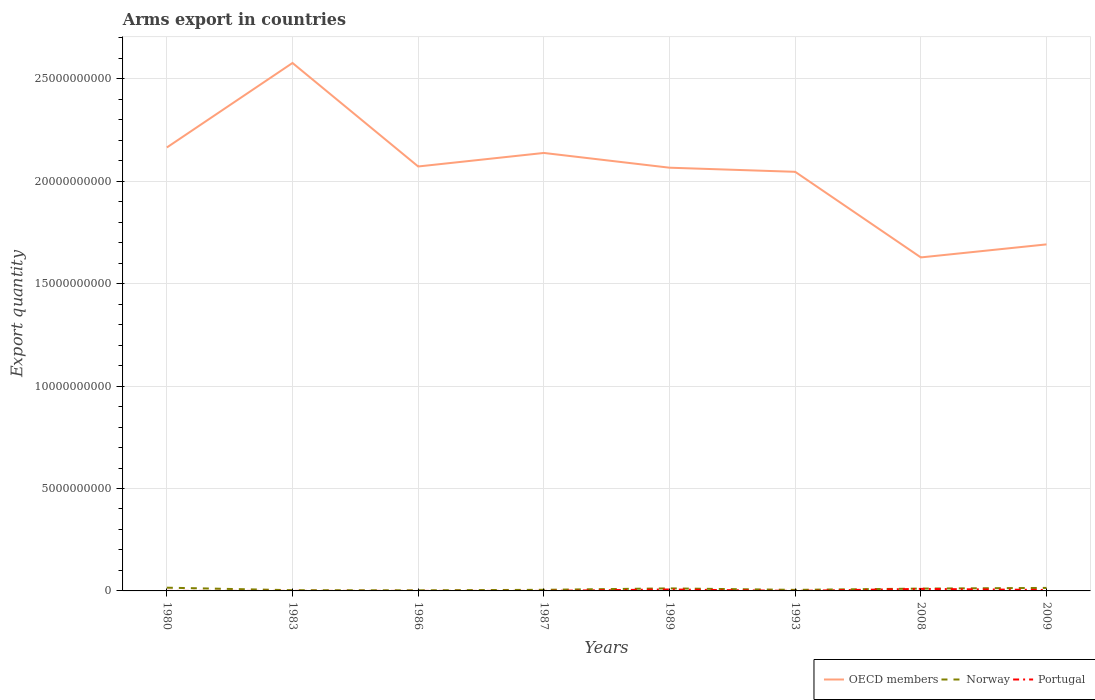Does the line corresponding to Portugal intersect with the line corresponding to Norway?
Your response must be concise. No. Across all years, what is the maximum total arms export in Norway?
Ensure brevity in your answer.  2.90e+07. What is the difference between the highest and the second highest total arms export in Norway?
Your response must be concise. 1.29e+08. What is the difference between the highest and the lowest total arms export in OECD members?
Provide a succinct answer. 5. Is the total arms export in Norway strictly greater than the total arms export in OECD members over the years?
Provide a short and direct response. Yes. Are the values on the major ticks of Y-axis written in scientific E-notation?
Offer a terse response. No. What is the title of the graph?
Offer a very short reply. Arms export in countries. Does "Northern Mariana Islands" appear as one of the legend labels in the graph?
Offer a terse response. No. What is the label or title of the Y-axis?
Your response must be concise. Export quantity. What is the Export quantity of OECD members in 1980?
Ensure brevity in your answer.  2.16e+1. What is the Export quantity in Norway in 1980?
Give a very brief answer. 1.58e+08. What is the Export quantity in OECD members in 1983?
Ensure brevity in your answer.  2.58e+1. What is the Export quantity of Norway in 1983?
Offer a very short reply. 3.50e+07. What is the Export quantity of Portugal in 1983?
Ensure brevity in your answer.  1.00e+06. What is the Export quantity in OECD members in 1986?
Give a very brief answer. 2.07e+1. What is the Export quantity of Norway in 1986?
Your answer should be compact. 2.90e+07. What is the Export quantity of OECD members in 1987?
Offer a terse response. 2.14e+1. What is the Export quantity in Norway in 1987?
Your answer should be compact. 5.40e+07. What is the Export quantity of OECD members in 1989?
Offer a terse response. 2.07e+1. What is the Export quantity of Norway in 1989?
Your answer should be compact. 1.24e+08. What is the Export quantity of Portugal in 1989?
Provide a short and direct response. 7.10e+07. What is the Export quantity of OECD members in 1993?
Provide a succinct answer. 2.05e+1. What is the Export quantity in Norway in 1993?
Your answer should be compact. 5.10e+07. What is the Export quantity of Portugal in 1993?
Your answer should be very brief. 1.00e+06. What is the Export quantity in OECD members in 2008?
Provide a short and direct response. 1.63e+1. What is the Export quantity in Norway in 2008?
Ensure brevity in your answer.  1.14e+08. What is the Export quantity in Portugal in 2008?
Your answer should be very brief. 9.90e+07. What is the Export quantity in OECD members in 2009?
Offer a terse response. 1.69e+1. What is the Export quantity of Norway in 2009?
Give a very brief answer. 1.47e+08. What is the Export quantity in Portugal in 2009?
Provide a succinct answer. 4.60e+07. Across all years, what is the maximum Export quantity of OECD members?
Provide a short and direct response. 2.58e+1. Across all years, what is the maximum Export quantity of Norway?
Offer a terse response. 1.58e+08. Across all years, what is the maximum Export quantity of Portugal?
Provide a succinct answer. 9.90e+07. Across all years, what is the minimum Export quantity of OECD members?
Your response must be concise. 1.63e+1. Across all years, what is the minimum Export quantity of Norway?
Keep it short and to the point. 2.90e+07. What is the total Export quantity in OECD members in the graph?
Your answer should be compact. 1.64e+11. What is the total Export quantity of Norway in the graph?
Make the answer very short. 7.12e+08. What is the total Export quantity of Portugal in the graph?
Make the answer very short. 2.21e+08. What is the difference between the Export quantity in OECD members in 1980 and that in 1983?
Your response must be concise. -4.13e+09. What is the difference between the Export quantity in Norway in 1980 and that in 1983?
Your response must be concise. 1.23e+08. What is the difference between the Export quantity in Portugal in 1980 and that in 1983?
Give a very brief answer. 0. What is the difference between the Export quantity in OECD members in 1980 and that in 1986?
Provide a short and direct response. 9.27e+08. What is the difference between the Export quantity in Norway in 1980 and that in 1986?
Provide a succinct answer. 1.29e+08. What is the difference between the Export quantity in Portugal in 1980 and that in 1986?
Your response must be concise. 0. What is the difference between the Export quantity of OECD members in 1980 and that in 1987?
Your answer should be very brief. 2.67e+08. What is the difference between the Export quantity of Norway in 1980 and that in 1987?
Make the answer very short. 1.04e+08. What is the difference between the Export quantity in Portugal in 1980 and that in 1987?
Provide a succinct answer. 0. What is the difference between the Export quantity of OECD members in 1980 and that in 1989?
Keep it short and to the point. 9.87e+08. What is the difference between the Export quantity in Norway in 1980 and that in 1989?
Give a very brief answer. 3.40e+07. What is the difference between the Export quantity of Portugal in 1980 and that in 1989?
Your response must be concise. -7.00e+07. What is the difference between the Export quantity in OECD members in 1980 and that in 1993?
Your answer should be very brief. 1.19e+09. What is the difference between the Export quantity in Norway in 1980 and that in 1993?
Your answer should be very brief. 1.07e+08. What is the difference between the Export quantity of Portugal in 1980 and that in 1993?
Your answer should be compact. 0. What is the difference between the Export quantity of OECD members in 1980 and that in 2008?
Offer a very short reply. 5.37e+09. What is the difference between the Export quantity of Norway in 1980 and that in 2008?
Keep it short and to the point. 4.40e+07. What is the difference between the Export quantity of Portugal in 1980 and that in 2008?
Your answer should be very brief. -9.80e+07. What is the difference between the Export quantity in OECD members in 1980 and that in 2009?
Ensure brevity in your answer.  4.73e+09. What is the difference between the Export quantity of Norway in 1980 and that in 2009?
Your answer should be very brief. 1.10e+07. What is the difference between the Export quantity of Portugal in 1980 and that in 2009?
Give a very brief answer. -4.50e+07. What is the difference between the Export quantity in OECD members in 1983 and that in 1986?
Offer a very short reply. 5.05e+09. What is the difference between the Export quantity of Norway in 1983 and that in 1986?
Offer a terse response. 6.00e+06. What is the difference between the Export quantity in Portugal in 1983 and that in 1986?
Give a very brief answer. 0. What is the difference between the Export quantity of OECD members in 1983 and that in 1987?
Provide a short and direct response. 4.39e+09. What is the difference between the Export quantity in Norway in 1983 and that in 1987?
Your answer should be very brief. -1.90e+07. What is the difference between the Export quantity of Portugal in 1983 and that in 1987?
Provide a succinct answer. 0. What is the difference between the Export quantity in OECD members in 1983 and that in 1989?
Provide a short and direct response. 5.11e+09. What is the difference between the Export quantity of Norway in 1983 and that in 1989?
Ensure brevity in your answer.  -8.90e+07. What is the difference between the Export quantity of Portugal in 1983 and that in 1989?
Your response must be concise. -7.00e+07. What is the difference between the Export quantity of OECD members in 1983 and that in 1993?
Your answer should be compact. 5.31e+09. What is the difference between the Export quantity of Norway in 1983 and that in 1993?
Ensure brevity in your answer.  -1.60e+07. What is the difference between the Export quantity in Portugal in 1983 and that in 1993?
Offer a terse response. 0. What is the difference between the Export quantity in OECD members in 1983 and that in 2008?
Keep it short and to the point. 9.49e+09. What is the difference between the Export quantity in Norway in 1983 and that in 2008?
Ensure brevity in your answer.  -7.90e+07. What is the difference between the Export quantity in Portugal in 1983 and that in 2008?
Provide a succinct answer. -9.80e+07. What is the difference between the Export quantity of OECD members in 1983 and that in 2009?
Make the answer very short. 8.86e+09. What is the difference between the Export quantity of Norway in 1983 and that in 2009?
Your answer should be compact. -1.12e+08. What is the difference between the Export quantity of Portugal in 1983 and that in 2009?
Offer a very short reply. -4.50e+07. What is the difference between the Export quantity of OECD members in 1986 and that in 1987?
Make the answer very short. -6.60e+08. What is the difference between the Export quantity of Norway in 1986 and that in 1987?
Provide a short and direct response. -2.50e+07. What is the difference between the Export quantity of OECD members in 1986 and that in 1989?
Your response must be concise. 6.00e+07. What is the difference between the Export quantity of Norway in 1986 and that in 1989?
Provide a short and direct response. -9.50e+07. What is the difference between the Export quantity in Portugal in 1986 and that in 1989?
Your answer should be compact. -7.00e+07. What is the difference between the Export quantity of OECD members in 1986 and that in 1993?
Your answer should be compact. 2.61e+08. What is the difference between the Export quantity in Norway in 1986 and that in 1993?
Offer a terse response. -2.20e+07. What is the difference between the Export quantity of Portugal in 1986 and that in 1993?
Provide a short and direct response. 0. What is the difference between the Export quantity in OECD members in 1986 and that in 2008?
Provide a short and direct response. 4.44e+09. What is the difference between the Export quantity of Norway in 1986 and that in 2008?
Give a very brief answer. -8.50e+07. What is the difference between the Export quantity of Portugal in 1986 and that in 2008?
Keep it short and to the point. -9.80e+07. What is the difference between the Export quantity in OECD members in 1986 and that in 2009?
Make the answer very short. 3.80e+09. What is the difference between the Export quantity of Norway in 1986 and that in 2009?
Provide a succinct answer. -1.18e+08. What is the difference between the Export quantity of Portugal in 1986 and that in 2009?
Keep it short and to the point. -4.50e+07. What is the difference between the Export quantity in OECD members in 1987 and that in 1989?
Make the answer very short. 7.20e+08. What is the difference between the Export quantity of Norway in 1987 and that in 1989?
Offer a very short reply. -7.00e+07. What is the difference between the Export quantity of Portugal in 1987 and that in 1989?
Make the answer very short. -7.00e+07. What is the difference between the Export quantity of OECD members in 1987 and that in 1993?
Provide a succinct answer. 9.21e+08. What is the difference between the Export quantity in OECD members in 1987 and that in 2008?
Offer a very short reply. 5.10e+09. What is the difference between the Export quantity in Norway in 1987 and that in 2008?
Provide a short and direct response. -6.00e+07. What is the difference between the Export quantity of Portugal in 1987 and that in 2008?
Make the answer very short. -9.80e+07. What is the difference between the Export quantity of OECD members in 1987 and that in 2009?
Provide a short and direct response. 4.46e+09. What is the difference between the Export quantity in Norway in 1987 and that in 2009?
Make the answer very short. -9.30e+07. What is the difference between the Export quantity of Portugal in 1987 and that in 2009?
Your answer should be compact. -4.50e+07. What is the difference between the Export quantity in OECD members in 1989 and that in 1993?
Make the answer very short. 2.01e+08. What is the difference between the Export quantity in Norway in 1989 and that in 1993?
Your answer should be very brief. 7.30e+07. What is the difference between the Export quantity in Portugal in 1989 and that in 1993?
Offer a terse response. 7.00e+07. What is the difference between the Export quantity in OECD members in 1989 and that in 2008?
Keep it short and to the point. 4.38e+09. What is the difference between the Export quantity of Portugal in 1989 and that in 2008?
Provide a succinct answer. -2.80e+07. What is the difference between the Export quantity of OECD members in 1989 and that in 2009?
Your answer should be compact. 3.74e+09. What is the difference between the Export quantity in Norway in 1989 and that in 2009?
Your response must be concise. -2.30e+07. What is the difference between the Export quantity in Portugal in 1989 and that in 2009?
Give a very brief answer. 2.50e+07. What is the difference between the Export quantity of OECD members in 1993 and that in 2008?
Your answer should be compact. 4.18e+09. What is the difference between the Export quantity in Norway in 1993 and that in 2008?
Make the answer very short. -6.30e+07. What is the difference between the Export quantity of Portugal in 1993 and that in 2008?
Offer a very short reply. -9.80e+07. What is the difference between the Export quantity in OECD members in 1993 and that in 2009?
Provide a short and direct response. 3.54e+09. What is the difference between the Export quantity of Norway in 1993 and that in 2009?
Provide a succinct answer. -9.60e+07. What is the difference between the Export quantity in Portugal in 1993 and that in 2009?
Make the answer very short. -4.50e+07. What is the difference between the Export quantity in OECD members in 2008 and that in 2009?
Your response must be concise. -6.36e+08. What is the difference between the Export quantity of Norway in 2008 and that in 2009?
Ensure brevity in your answer.  -3.30e+07. What is the difference between the Export quantity in Portugal in 2008 and that in 2009?
Give a very brief answer. 5.30e+07. What is the difference between the Export quantity of OECD members in 1980 and the Export quantity of Norway in 1983?
Offer a very short reply. 2.16e+1. What is the difference between the Export quantity in OECD members in 1980 and the Export quantity in Portugal in 1983?
Give a very brief answer. 2.16e+1. What is the difference between the Export quantity of Norway in 1980 and the Export quantity of Portugal in 1983?
Ensure brevity in your answer.  1.57e+08. What is the difference between the Export quantity in OECD members in 1980 and the Export quantity in Norway in 1986?
Provide a short and direct response. 2.16e+1. What is the difference between the Export quantity in OECD members in 1980 and the Export quantity in Portugal in 1986?
Give a very brief answer. 2.16e+1. What is the difference between the Export quantity of Norway in 1980 and the Export quantity of Portugal in 1986?
Provide a succinct answer. 1.57e+08. What is the difference between the Export quantity of OECD members in 1980 and the Export quantity of Norway in 1987?
Make the answer very short. 2.16e+1. What is the difference between the Export quantity in OECD members in 1980 and the Export quantity in Portugal in 1987?
Provide a succinct answer. 2.16e+1. What is the difference between the Export quantity of Norway in 1980 and the Export quantity of Portugal in 1987?
Offer a very short reply. 1.57e+08. What is the difference between the Export quantity in OECD members in 1980 and the Export quantity in Norway in 1989?
Provide a short and direct response. 2.15e+1. What is the difference between the Export quantity in OECD members in 1980 and the Export quantity in Portugal in 1989?
Offer a very short reply. 2.16e+1. What is the difference between the Export quantity of Norway in 1980 and the Export quantity of Portugal in 1989?
Your response must be concise. 8.70e+07. What is the difference between the Export quantity of OECD members in 1980 and the Export quantity of Norway in 1993?
Provide a succinct answer. 2.16e+1. What is the difference between the Export quantity in OECD members in 1980 and the Export quantity in Portugal in 1993?
Ensure brevity in your answer.  2.16e+1. What is the difference between the Export quantity in Norway in 1980 and the Export quantity in Portugal in 1993?
Your answer should be compact. 1.57e+08. What is the difference between the Export quantity in OECD members in 1980 and the Export quantity in Norway in 2008?
Your answer should be compact. 2.15e+1. What is the difference between the Export quantity in OECD members in 1980 and the Export quantity in Portugal in 2008?
Your response must be concise. 2.16e+1. What is the difference between the Export quantity of Norway in 1980 and the Export quantity of Portugal in 2008?
Give a very brief answer. 5.90e+07. What is the difference between the Export quantity in OECD members in 1980 and the Export quantity in Norway in 2009?
Your answer should be very brief. 2.15e+1. What is the difference between the Export quantity of OECD members in 1980 and the Export quantity of Portugal in 2009?
Your response must be concise. 2.16e+1. What is the difference between the Export quantity of Norway in 1980 and the Export quantity of Portugal in 2009?
Provide a succinct answer. 1.12e+08. What is the difference between the Export quantity of OECD members in 1983 and the Export quantity of Norway in 1986?
Make the answer very short. 2.57e+1. What is the difference between the Export quantity in OECD members in 1983 and the Export quantity in Portugal in 1986?
Your response must be concise. 2.58e+1. What is the difference between the Export quantity of Norway in 1983 and the Export quantity of Portugal in 1986?
Ensure brevity in your answer.  3.40e+07. What is the difference between the Export quantity of OECD members in 1983 and the Export quantity of Norway in 1987?
Your answer should be very brief. 2.57e+1. What is the difference between the Export quantity in OECD members in 1983 and the Export quantity in Portugal in 1987?
Your answer should be compact. 2.58e+1. What is the difference between the Export quantity of Norway in 1983 and the Export quantity of Portugal in 1987?
Offer a very short reply. 3.40e+07. What is the difference between the Export quantity in OECD members in 1983 and the Export quantity in Norway in 1989?
Your response must be concise. 2.57e+1. What is the difference between the Export quantity in OECD members in 1983 and the Export quantity in Portugal in 1989?
Your answer should be compact. 2.57e+1. What is the difference between the Export quantity in Norway in 1983 and the Export quantity in Portugal in 1989?
Keep it short and to the point. -3.60e+07. What is the difference between the Export quantity of OECD members in 1983 and the Export quantity of Norway in 1993?
Provide a short and direct response. 2.57e+1. What is the difference between the Export quantity of OECD members in 1983 and the Export quantity of Portugal in 1993?
Your response must be concise. 2.58e+1. What is the difference between the Export quantity of Norway in 1983 and the Export quantity of Portugal in 1993?
Offer a terse response. 3.40e+07. What is the difference between the Export quantity of OECD members in 1983 and the Export quantity of Norway in 2008?
Give a very brief answer. 2.57e+1. What is the difference between the Export quantity of OECD members in 1983 and the Export quantity of Portugal in 2008?
Your response must be concise. 2.57e+1. What is the difference between the Export quantity in Norway in 1983 and the Export quantity in Portugal in 2008?
Keep it short and to the point. -6.40e+07. What is the difference between the Export quantity of OECD members in 1983 and the Export quantity of Norway in 2009?
Provide a short and direct response. 2.56e+1. What is the difference between the Export quantity of OECD members in 1983 and the Export quantity of Portugal in 2009?
Provide a succinct answer. 2.57e+1. What is the difference between the Export quantity of Norway in 1983 and the Export quantity of Portugal in 2009?
Provide a succinct answer. -1.10e+07. What is the difference between the Export quantity in OECD members in 1986 and the Export quantity in Norway in 1987?
Your response must be concise. 2.07e+1. What is the difference between the Export quantity of OECD members in 1986 and the Export quantity of Portugal in 1987?
Offer a terse response. 2.07e+1. What is the difference between the Export quantity of Norway in 1986 and the Export quantity of Portugal in 1987?
Provide a succinct answer. 2.80e+07. What is the difference between the Export quantity in OECD members in 1986 and the Export quantity in Norway in 1989?
Your answer should be compact. 2.06e+1. What is the difference between the Export quantity of OECD members in 1986 and the Export quantity of Portugal in 1989?
Offer a very short reply. 2.07e+1. What is the difference between the Export quantity in Norway in 1986 and the Export quantity in Portugal in 1989?
Provide a succinct answer. -4.20e+07. What is the difference between the Export quantity of OECD members in 1986 and the Export quantity of Norway in 1993?
Provide a succinct answer. 2.07e+1. What is the difference between the Export quantity of OECD members in 1986 and the Export quantity of Portugal in 1993?
Offer a very short reply. 2.07e+1. What is the difference between the Export quantity in Norway in 1986 and the Export quantity in Portugal in 1993?
Keep it short and to the point. 2.80e+07. What is the difference between the Export quantity of OECD members in 1986 and the Export quantity of Norway in 2008?
Provide a succinct answer. 2.06e+1. What is the difference between the Export quantity in OECD members in 1986 and the Export quantity in Portugal in 2008?
Your response must be concise. 2.06e+1. What is the difference between the Export quantity in Norway in 1986 and the Export quantity in Portugal in 2008?
Make the answer very short. -7.00e+07. What is the difference between the Export quantity in OECD members in 1986 and the Export quantity in Norway in 2009?
Your answer should be compact. 2.06e+1. What is the difference between the Export quantity in OECD members in 1986 and the Export quantity in Portugal in 2009?
Give a very brief answer. 2.07e+1. What is the difference between the Export quantity in Norway in 1986 and the Export quantity in Portugal in 2009?
Provide a succinct answer. -1.70e+07. What is the difference between the Export quantity in OECD members in 1987 and the Export quantity in Norway in 1989?
Make the answer very short. 2.13e+1. What is the difference between the Export quantity in OECD members in 1987 and the Export quantity in Portugal in 1989?
Offer a terse response. 2.13e+1. What is the difference between the Export quantity in Norway in 1987 and the Export quantity in Portugal in 1989?
Offer a very short reply. -1.70e+07. What is the difference between the Export quantity of OECD members in 1987 and the Export quantity of Norway in 1993?
Ensure brevity in your answer.  2.13e+1. What is the difference between the Export quantity in OECD members in 1987 and the Export quantity in Portugal in 1993?
Your response must be concise. 2.14e+1. What is the difference between the Export quantity of Norway in 1987 and the Export quantity of Portugal in 1993?
Give a very brief answer. 5.30e+07. What is the difference between the Export quantity of OECD members in 1987 and the Export quantity of Norway in 2008?
Offer a very short reply. 2.13e+1. What is the difference between the Export quantity in OECD members in 1987 and the Export quantity in Portugal in 2008?
Your response must be concise. 2.13e+1. What is the difference between the Export quantity of Norway in 1987 and the Export quantity of Portugal in 2008?
Make the answer very short. -4.50e+07. What is the difference between the Export quantity in OECD members in 1987 and the Export quantity in Norway in 2009?
Offer a terse response. 2.12e+1. What is the difference between the Export quantity of OECD members in 1987 and the Export quantity of Portugal in 2009?
Provide a succinct answer. 2.13e+1. What is the difference between the Export quantity of Norway in 1987 and the Export quantity of Portugal in 2009?
Keep it short and to the point. 8.00e+06. What is the difference between the Export quantity of OECD members in 1989 and the Export quantity of Norway in 1993?
Make the answer very short. 2.06e+1. What is the difference between the Export quantity in OECD members in 1989 and the Export quantity in Portugal in 1993?
Your response must be concise. 2.07e+1. What is the difference between the Export quantity of Norway in 1989 and the Export quantity of Portugal in 1993?
Provide a short and direct response. 1.23e+08. What is the difference between the Export quantity of OECD members in 1989 and the Export quantity of Norway in 2008?
Your answer should be compact. 2.05e+1. What is the difference between the Export quantity in OECD members in 1989 and the Export quantity in Portugal in 2008?
Your answer should be compact. 2.06e+1. What is the difference between the Export quantity of Norway in 1989 and the Export quantity of Portugal in 2008?
Your response must be concise. 2.50e+07. What is the difference between the Export quantity in OECD members in 1989 and the Export quantity in Norway in 2009?
Provide a short and direct response. 2.05e+1. What is the difference between the Export quantity in OECD members in 1989 and the Export quantity in Portugal in 2009?
Your answer should be compact. 2.06e+1. What is the difference between the Export quantity of Norway in 1989 and the Export quantity of Portugal in 2009?
Offer a terse response. 7.80e+07. What is the difference between the Export quantity in OECD members in 1993 and the Export quantity in Norway in 2008?
Ensure brevity in your answer.  2.03e+1. What is the difference between the Export quantity of OECD members in 1993 and the Export quantity of Portugal in 2008?
Provide a succinct answer. 2.04e+1. What is the difference between the Export quantity of Norway in 1993 and the Export quantity of Portugal in 2008?
Provide a short and direct response. -4.80e+07. What is the difference between the Export quantity in OECD members in 1993 and the Export quantity in Norway in 2009?
Ensure brevity in your answer.  2.03e+1. What is the difference between the Export quantity of OECD members in 1993 and the Export quantity of Portugal in 2009?
Provide a succinct answer. 2.04e+1. What is the difference between the Export quantity in Norway in 1993 and the Export quantity in Portugal in 2009?
Keep it short and to the point. 5.00e+06. What is the difference between the Export quantity of OECD members in 2008 and the Export quantity of Norway in 2009?
Your answer should be compact. 1.61e+1. What is the difference between the Export quantity in OECD members in 2008 and the Export quantity in Portugal in 2009?
Provide a short and direct response. 1.62e+1. What is the difference between the Export quantity in Norway in 2008 and the Export quantity in Portugal in 2009?
Offer a terse response. 6.80e+07. What is the average Export quantity of OECD members per year?
Keep it short and to the point. 2.05e+1. What is the average Export quantity in Norway per year?
Keep it short and to the point. 8.90e+07. What is the average Export quantity in Portugal per year?
Provide a short and direct response. 2.76e+07. In the year 1980, what is the difference between the Export quantity of OECD members and Export quantity of Norway?
Provide a succinct answer. 2.15e+1. In the year 1980, what is the difference between the Export quantity of OECD members and Export quantity of Portugal?
Provide a short and direct response. 2.16e+1. In the year 1980, what is the difference between the Export quantity in Norway and Export quantity in Portugal?
Your answer should be very brief. 1.57e+08. In the year 1983, what is the difference between the Export quantity of OECD members and Export quantity of Norway?
Your answer should be very brief. 2.57e+1. In the year 1983, what is the difference between the Export quantity in OECD members and Export quantity in Portugal?
Your answer should be compact. 2.58e+1. In the year 1983, what is the difference between the Export quantity in Norway and Export quantity in Portugal?
Provide a short and direct response. 3.40e+07. In the year 1986, what is the difference between the Export quantity of OECD members and Export quantity of Norway?
Ensure brevity in your answer.  2.07e+1. In the year 1986, what is the difference between the Export quantity in OECD members and Export quantity in Portugal?
Offer a terse response. 2.07e+1. In the year 1986, what is the difference between the Export quantity of Norway and Export quantity of Portugal?
Provide a short and direct response. 2.80e+07. In the year 1987, what is the difference between the Export quantity in OECD members and Export quantity in Norway?
Keep it short and to the point. 2.13e+1. In the year 1987, what is the difference between the Export quantity in OECD members and Export quantity in Portugal?
Offer a terse response. 2.14e+1. In the year 1987, what is the difference between the Export quantity in Norway and Export quantity in Portugal?
Your response must be concise. 5.30e+07. In the year 1989, what is the difference between the Export quantity of OECD members and Export quantity of Norway?
Your response must be concise. 2.05e+1. In the year 1989, what is the difference between the Export quantity in OECD members and Export quantity in Portugal?
Give a very brief answer. 2.06e+1. In the year 1989, what is the difference between the Export quantity in Norway and Export quantity in Portugal?
Provide a short and direct response. 5.30e+07. In the year 1993, what is the difference between the Export quantity of OECD members and Export quantity of Norway?
Offer a terse response. 2.04e+1. In the year 1993, what is the difference between the Export quantity in OECD members and Export quantity in Portugal?
Ensure brevity in your answer.  2.05e+1. In the year 2008, what is the difference between the Export quantity of OECD members and Export quantity of Norway?
Your answer should be very brief. 1.62e+1. In the year 2008, what is the difference between the Export quantity of OECD members and Export quantity of Portugal?
Offer a very short reply. 1.62e+1. In the year 2008, what is the difference between the Export quantity of Norway and Export quantity of Portugal?
Keep it short and to the point. 1.50e+07. In the year 2009, what is the difference between the Export quantity of OECD members and Export quantity of Norway?
Offer a very short reply. 1.68e+1. In the year 2009, what is the difference between the Export quantity in OECD members and Export quantity in Portugal?
Make the answer very short. 1.69e+1. In the year 2009, what is the difference between the Export quantity in Norway and Export quantity in Portugal?
Provide a succinct answer. 1.01e+08. What is the ratio of the Export quantity in OECD members in 1980 to that in 1983?
Make the answer very short. 0.84. What is the ratio of the Export quantity of Norway in 1980 to that in 1983?
Ensure brevity in your answer.  4.51. What is the ratio of the Export quantity in OECD members in 1980 to that in 1986?
Your response must be concise. 1.04. What is the ratio of the Export quantity of Norway in 1980 to that in 1986?
Your answer should be compact. 5.45. What is the ratio of the Export quantity in OECD members in 1980 to that in 1987?
Offer a very short reply. 1.01. What is the ratio of the Export quantity in Norway in 1980 to that in 1987?
Ensure brevity in your answer.  2.93. What is the ratio of the Export quantity in Portugal in 1980 to that in 1987?
Offer a terse response. 1. What is the ratio of the Export quantity of OECD members in 1980 to that in 1989?
Make the answer very short. 1.05. What is the ratio of the Export quantity of Norway in 1980 to that in 1989?
Your response must be concise. 1.27. What is the ratio of the Export quantity of Portugal in 1980 to that in 1989?
Your answer should be very brief. 0.01. What is the ratio of the Export quantity in OECD members in 1980 to that in 1993?
Ensure brevity in your answer.  1.06. What is the ratio of the Export quantity of Norway in 1980 to that in 1993?
Your response must be concise. 3.1. What is the ratio of the Export quantity in OECD members in 1980 to that in 2008?
Offer a very short reply. 1.33. What is the ratio of the Export quantity in Norway in 1980 to that in 2008?
Give a very brief answer. 1.39. What is the ratio of the Export quantity of Portugal in 1980 to that in 2008?
Your answer should be compact. 0.01. What is the ratio of the Export quantity in OECD members in 1980 to that in 2009?
Ensure brevity in your answer.  1.28. What is the ratio of the Export quantity in Norway in 1980 to that in 2009?
Your answer should be compact. 1.07. What is the ratio of the Export quantity in Portugal in 1980 to that in 2009?
Offer a terse response. 0.02. What is the ratio of the Export quantity of OECD members in 1983 to that in 1986?
Keep it short and to the point. 1.24. What is the ratio of the Export quantity in Norway in 1983 to that in 1986?
Keep it short and to the point. 1.21. What is the ratio of the Export quantity of Portugal in 1983 to that in 1986?
Provide a short and direct response. 1. What is the ratio of the Export quantity of OECD members in 1983 to that in 1987?
Your answer should be very brief. 1.21. What is the ratio of the Export quantity of Norway in 1983 to that in 1987?
Keep it short and to the point. 0.65. What is the ratio of the Export quantity of Portugal in 1983 to that in 1987?
Keep it short and to the point. 1. What is the ratio of the Export quantity of OECD members in 1983 to that in 1989?
Your answer should be very brief. 1.25. What is the ratio of the Export quantity in Norway in 1983 to that in 1989?
Offer a terse response. 0.28. What is the ratio of the Export quantity of Portugal in 1983 to that in 1989?
Make the answer very short. 0.01. What is the ratio of the Export quantity of OECD members in 1983 to that in 1993?
Provide a short and direct response. 1.26. What is the ratio of the Export quantity of Norway in 1983 to that in 1993?
Make the answer very short. 0.69. What is the ratio of the Export quantity in OECD members in 1983 to that in 2008?
Your response must be concise. 1.58. What is the ratio of the Export quantity of Norway in 1983 to that in 2008?
Provide a short and direct response. 0.31. What is the ratio of the Export quantity of Portugal in 1983 to that in 2008?
Your answer should be compact. 0.01. What is the ratio of the Export quantity in OECD members in 1983 to that in 2009?
Your response must be concise. 1.52. What is the ratio of the Export quantity of Norway in 1983 to that in 2009?
Provide a succinct answer. 0.24. What is the ratio of the Export quantity in Portugal in 1983 to that in 2009?
Ensure brevity in your answer.  0.02. What is the ratio of the Export quantity in OECD members in 1986 to that in 1987?
Ensure brevity in your answer.  0.97. What is the ratio of the Export quantity of Norway in 1986 to that in 1987?
Ensure brevity in your answer.  0.54. What is the ratio of the Export quantity in Portugal in 1986 to that in 1987?
Keep it short and to the point. 1. What is the ratio of the Export quantity of Norway in 1986 to that in 1989?
Your answer should be compact. 0.23. What is the ratio of the Export quantity in Portugal in 1986 to that in 1989?
Make the answer very short. 0.01. What is the ratio of the Export quantity in OECD members in 1986 to that in 1993?
Offer a terse response. 1.01. What is the ratio of the Export quantity in Norway in 1986 to that in 1993?
Your response must be concise. 0.57. What is the ratio of the Export quantity in Portugal in 1986 to that in 1993?
Offer a very short reply. 1. What is the ratio of the Export quantity of OECD members in 1986 to that in 2008?
Your answer should be very brief. 1.27. What is the ratio of the Export quantity in Norway in 1986 to that in 2008?
Offer a terse response. 0.25. What is the ratio of the Export quantity of Portugal in 1986 to that in 2008?
Your answer should be compact. 0.01. What is the ratio of the Export quantity of OECD members in 1986 to that in 2009?
Ensure brevity in your answer.  1.22. What is the ratio of the Export quantity in Norway in 1986 to that in 2009?
Offer a terse response. 0.2. What is the ratio of the Export quantity in Portugal in 1986 to that in 2009?
Your answer should be compact. 0.02. What is the ratio of the Export quantity of OECD members in 1987 to that in 1989?
Offer a terse response. 1.03. What is the ratio of the Export quantity of Norway in 1987 to that in 1989?
Offer a very short reply. 0.44. What is the ratio of the Export quantity in Portugal in 1987 to that in 1989?
Give a very brief answer. 0.01. What is the ratio of the Export quantity of OECD members in 1987 to that in 1993?
Offer a terse response. 1.04. What is the ratio of the Export quantity of Norway in 1987 to that in 1993?
Your answer should be compact. 1.06. What is the ratio of the Export quantity of Portugal in 1987 to that in 1993?
Ensure brevity in your answer.  1. What is the ratio of the Export quantity of OECD members in 1987 to that in 2008?
Offer a terse response. 1.31. What is the ratio of the Export quantity of Norway in 1987 to that in 2008?
Offer a terse response. 0.47. What is the ratio of the Export quantity in Portugal in 1987 to that in 2008?
Offer a very short reply. 0.01. What is the ratio of the Export quantity of OECD members in 1987 to that in 2009?
Give a very brief answer. 1.26. What is the ratio of the Export quantity of Norway in 1987 to that in 2009?
Provide a succinct answer. 0.37. What is the ratio of the Export quantity in Portugal in 1987 to that in 2009?
Your answer should be very brief. 0.02. What is the ratio of the Export quantity of OECD members in 1989 to that in 1993?
Offer a very short reply. 1.01. What is the ratio of the Export quantity of Norway in 1989 to that in 1993?
Offer a very short reply. 2.43. What is the ratio of the Export quantity of Portugal in 1989 to that in 1993?
Give a very brief answer. 71. What is the ratio of the Export quantity in OECD members in 1989 to that in 2008?
Offer a very short reply. 1.27. What is the ratio of the Export quantity in Norway in 1989 to that in 2008?
Your response must be concise. 1.09. What is the ratio of the Export quantity in Portugal in 1989 to that in 2008?
Give a very brief answer. 0.72. What is the ratio of the Export quantity in OECD members in 1989 to that in 2009?
Your answer should be very brief. 1.22. What is the ratio of the Export quantity of Norway in 1989 to that in 2009?
Make the answer very short. 0.84. What is the ratio of the Export quantity of Portugal in 1989 to that in 2009?
Ensure brevity in your answer.  1.54. What is the ratio of the Export quantity in OECD members in 1993 to that in 2008?
Offer a very short reply. 1.26. What is the ratio of the Export quantity of Norway in 1993 to that in 2008?
Make the answer very short. 0.45. What is the ratio of the Export quantity in Portugal in 1993 to that in 2008?
Your response must be concise. 0.01. What is the ratio of the Export quantity of OECD members in 1993 to that in 2009?
Offer a terse response. 1.21. What is the ratio of the Export quantity in Norway in 1993 to that in 2009?
Offer a terse response. 0.35. What is the ratio of the Export quantity of Portugal in 1993 to that in 2009?
Your response must be concise. 0.02. What is the ratio of the Export quantity in OECD members in 2008 to that in 2009?
Provide a short and direct response. 0.96. What is the ratio of the Export quantity in Norway in 2008 to that in 2009?
Your response must be concise. 0.78. What is the ratio of the Export quantity in Portugal in 2008 to that in 2009?
Provide a short and direct response. 2.15. What is the difference between the highest and the second highest Export quantity of OECD members?
Provide a short and direct response. 4.13e+09. What is the difference between the highest and the second highest Export quantity in Norway?
Your answer should be compact. 1.10e+07. What is the difference between the highest and the second highest Export quantity of Portugal?
Ensure brevity in your answer.  2.80e+07. What is the difference between the highest and the lowest Export quantity of OECD members?
Offer a terse response. 9.49e+09. What is the difference between the highest and the lowest Export quantity of Norway?
Your answer should be compact. 1.29e+08. What is the difference between the highest and the lowest Export quantity in Portugal?
Make the answer very short. 9.80e+07. 